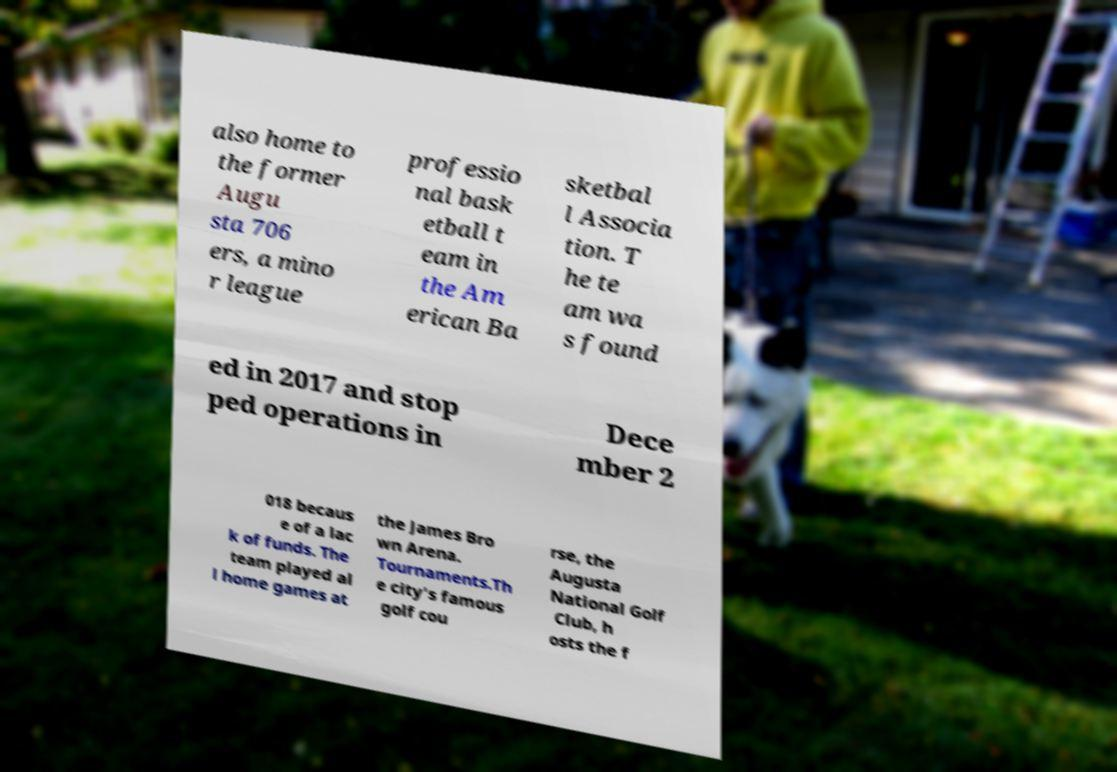Could you extract and type out the text from this image? also home to the former Augu sta 706 ers, a mino r league professio nal bask etball t eam in the Am erican Ba sketbal l Associa tion. T he te am wa s found ed in 2017 and stop ped operations in Dece mber 2 018 becaus e of a lac k of funds. The team played al l home games at the James Bro wn Arena. Tournaments.Th e city's famous golf cou rse, the Augusta National Golf Club, h osts the f 